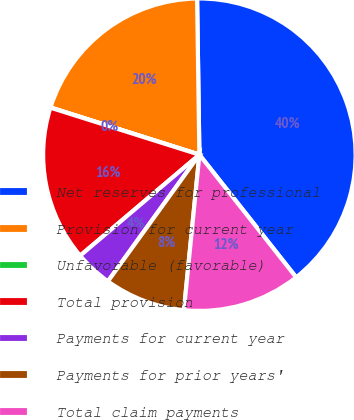<chart> <loc_0><loc_0><loc_500><loc_500><pie_chart><fcel>Net reserves for professional<fcel>Provision for current year<fcel>Unfavorable (favorable)<fcel>Total provision<fcel>Payments for current year<fcel>Payments for prior years'<fcel>Total claim payments<nl><fcel>39.6%<fcel>19.88%<fcel>0.02%<fcel>16.05%<fcel>3.86%<fcel>8.38%<fcel>12.21%<nl></chart> 